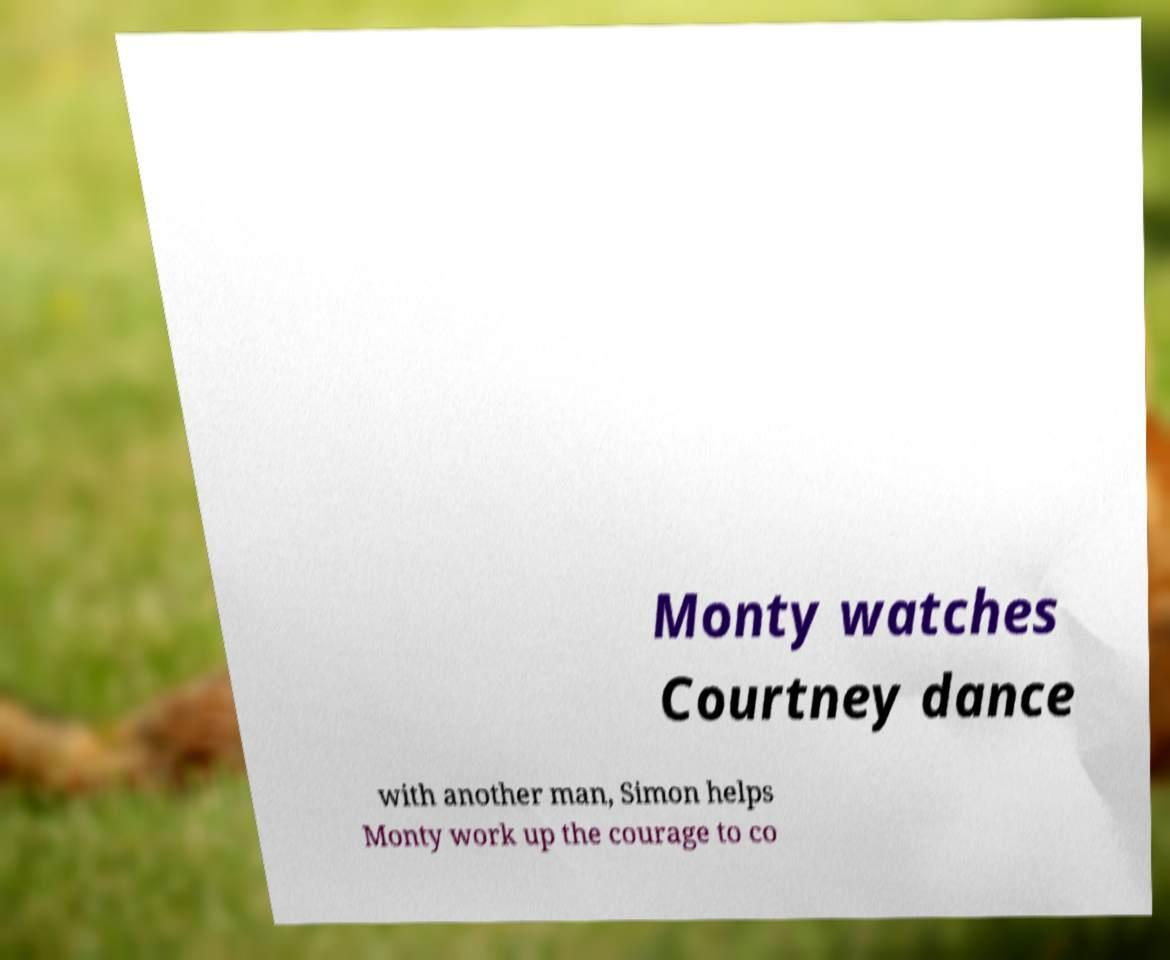Can you read and provide the text displayed in the image?This photo seems to have some interesting text. Can you extract and type it out for me? Monty watches Courtney dance with another man, Simon helps Monty work up the courage to co 